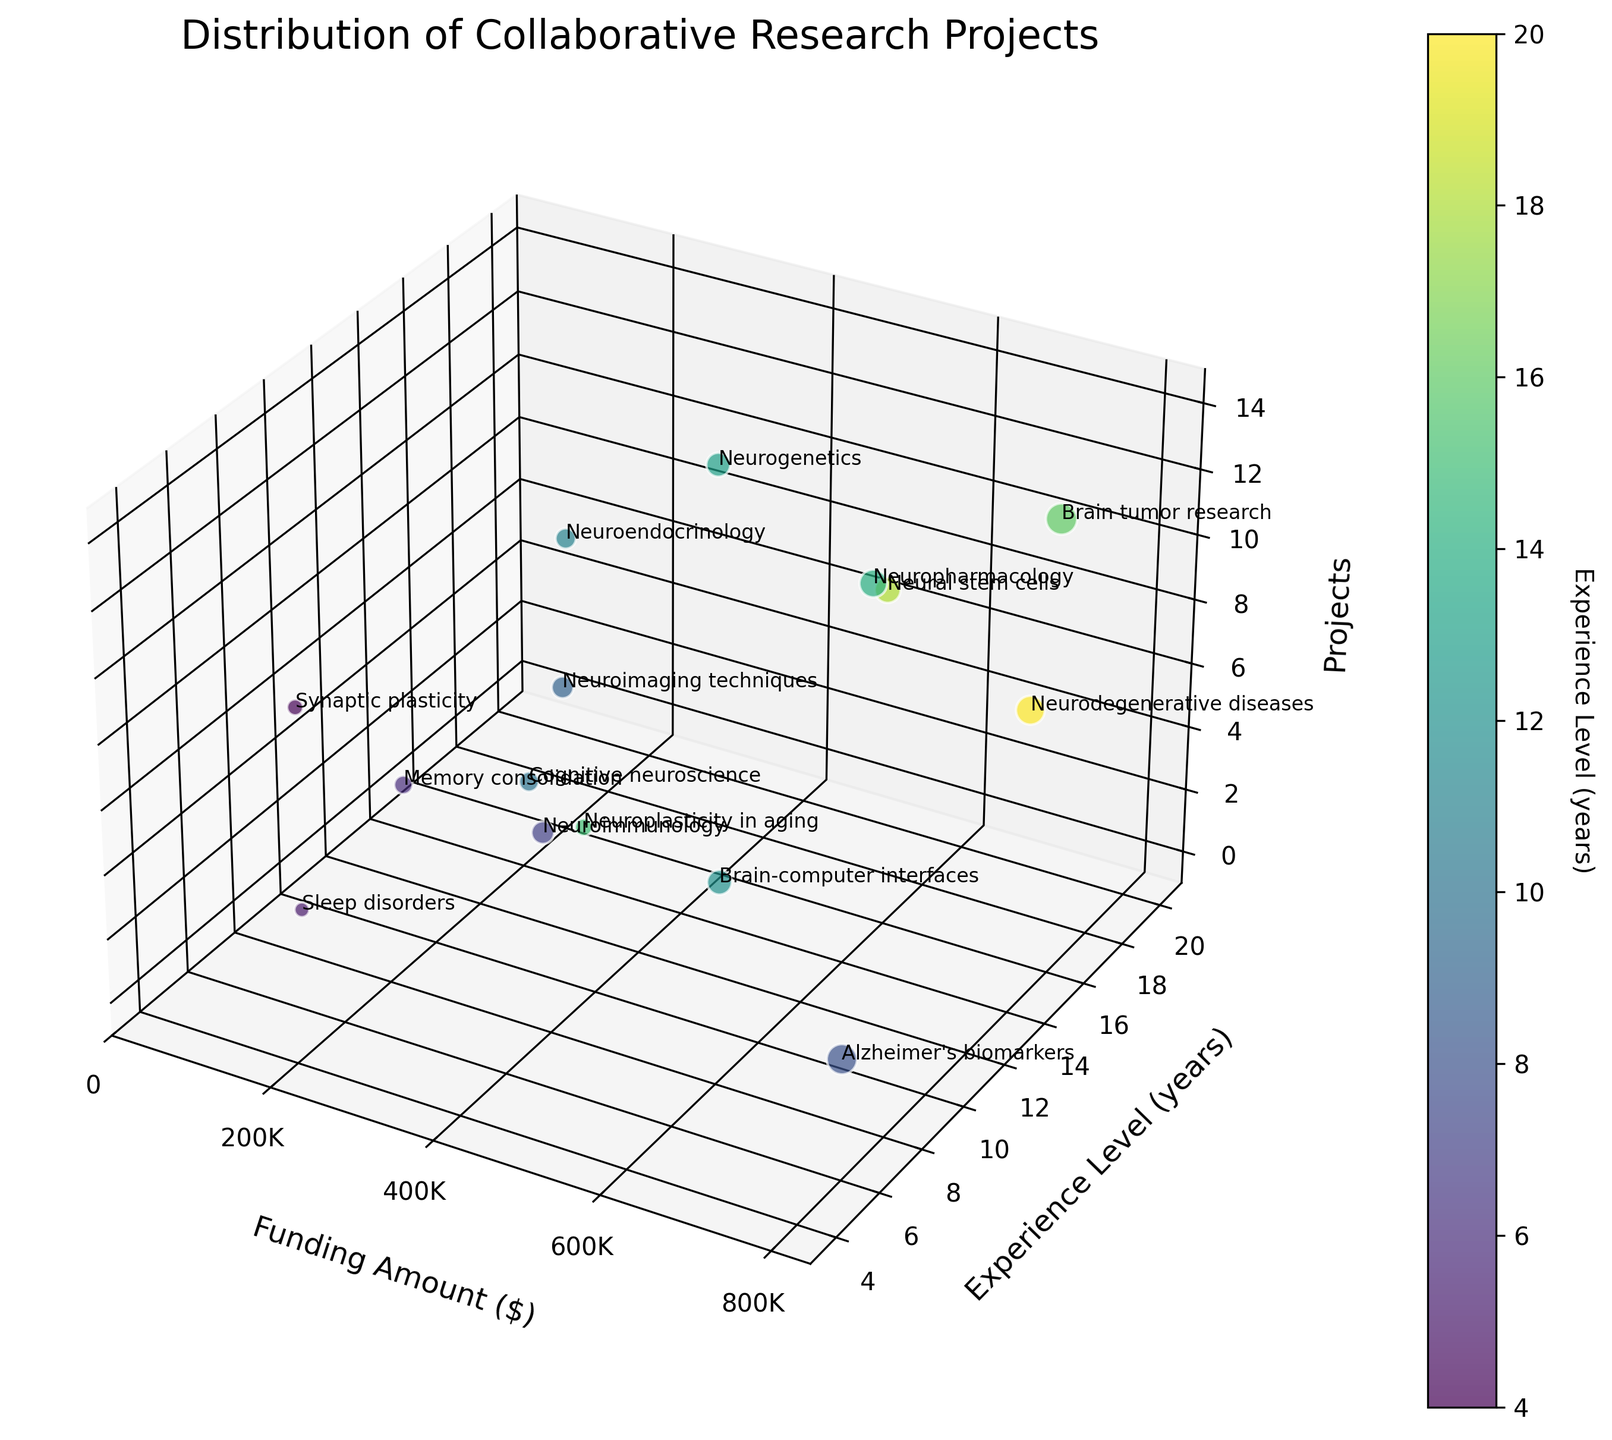How many projects are displayed in the scatter plot? To determine the number of projects, we count the data points in the scatter plot. Each data point represents one project. There are 15 data points visible in the plot.
Answer: 15 What does the color of the data points indicate in the scatter plot? The color of the data points corresponds to the 'Experience Level' of the researchers involved in the projects. This is indicated by the color bar labeled 'Experience Level (years)'.
Answer: Experience Level Which research project has the highest funding amount? The 'Brain tumor research' project is located at the highest point on the x-axis, which is labeled 'Funding Amount ($)', indicating that it has the highest funding.
Answer: Brain tumor research What is the range of experience levels observed in the projects? To find the range, we identify the minimum and maximum values from the 'Experience Level' axis. The minimum experience level is labeled as 4 years and the maximum is 20 years.
Answer: 4 to 20 years Which project has the lowest experience level and what is its funding amount? The project with the lowest experience level, 4 years, is 'Synaptic plasticity'. By finding and reading its position on the funding amount axis, we see that it has $210,000 in funding.
Answer: Synaptic plasticity, $210,000 What is the average funding amount of all the displayed projects? To find the average funding amount, we sum up all the funding amounts and divide by the number of projects: (250000 + 750000 + 500000 + 180000 + 680000 + 320000 + 420000 + 280000 + 550000 + 390000 + 210000 + 630000 + 340000 + 800000 + 470000) / 15 ≈ 427,333.33. The average funding amount is $427,333.33.
Answer: $427,333.33 How does funding amount correlate with experience level? By examining the scatter plot, it’s apparent that there is no clear linear correlation between funding amount and experience level, as projects with high and low funding are spread across different experience levels.
Answer: No clear linear correlation Which project has the highest correlation between funding and experience level, based on their data points? To determine the highest correlation, find the project with both high funding and high experience level; 'Neurodegenerative diseases' stands out with $680,000 funding and 20 years of experience.
Answer: Neurodegenerative diseases What is the funding amount and experience level for the 'Neuropharmacology' project? Locate the 'Neuropharmacology' data point in the scatter plot to find its position on the x-axis and y-axis. The funding amount is $630,000, and the experience level is 14 years.
Answer: $630,000, 14 years 